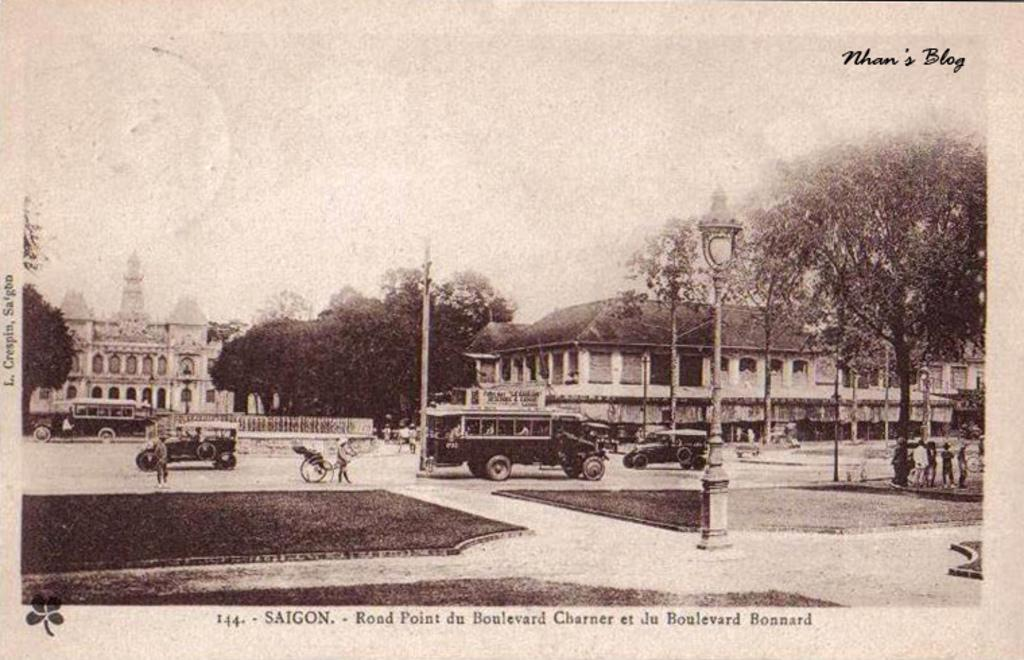<image>
Give a short and clear explanation of the subsequent image. A black and white photo that says Nhan's Blog in the upper corner. 